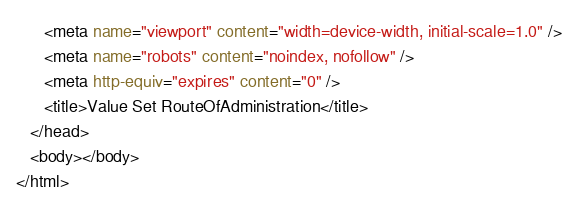Convert code to text. <code><loc_0><loc_0><loc_500><loc_500><_HTML_>      <meta name="viewport" content="width=device-width, initial-scale=1.0" />
      <meta name="robots" content="noindex, nofollow" />
      <meta http-equiv="expires" content="0" />
      <title>Value Set RouteOfAdministration</title>
   </head>
   <body></body>
</html></code> 